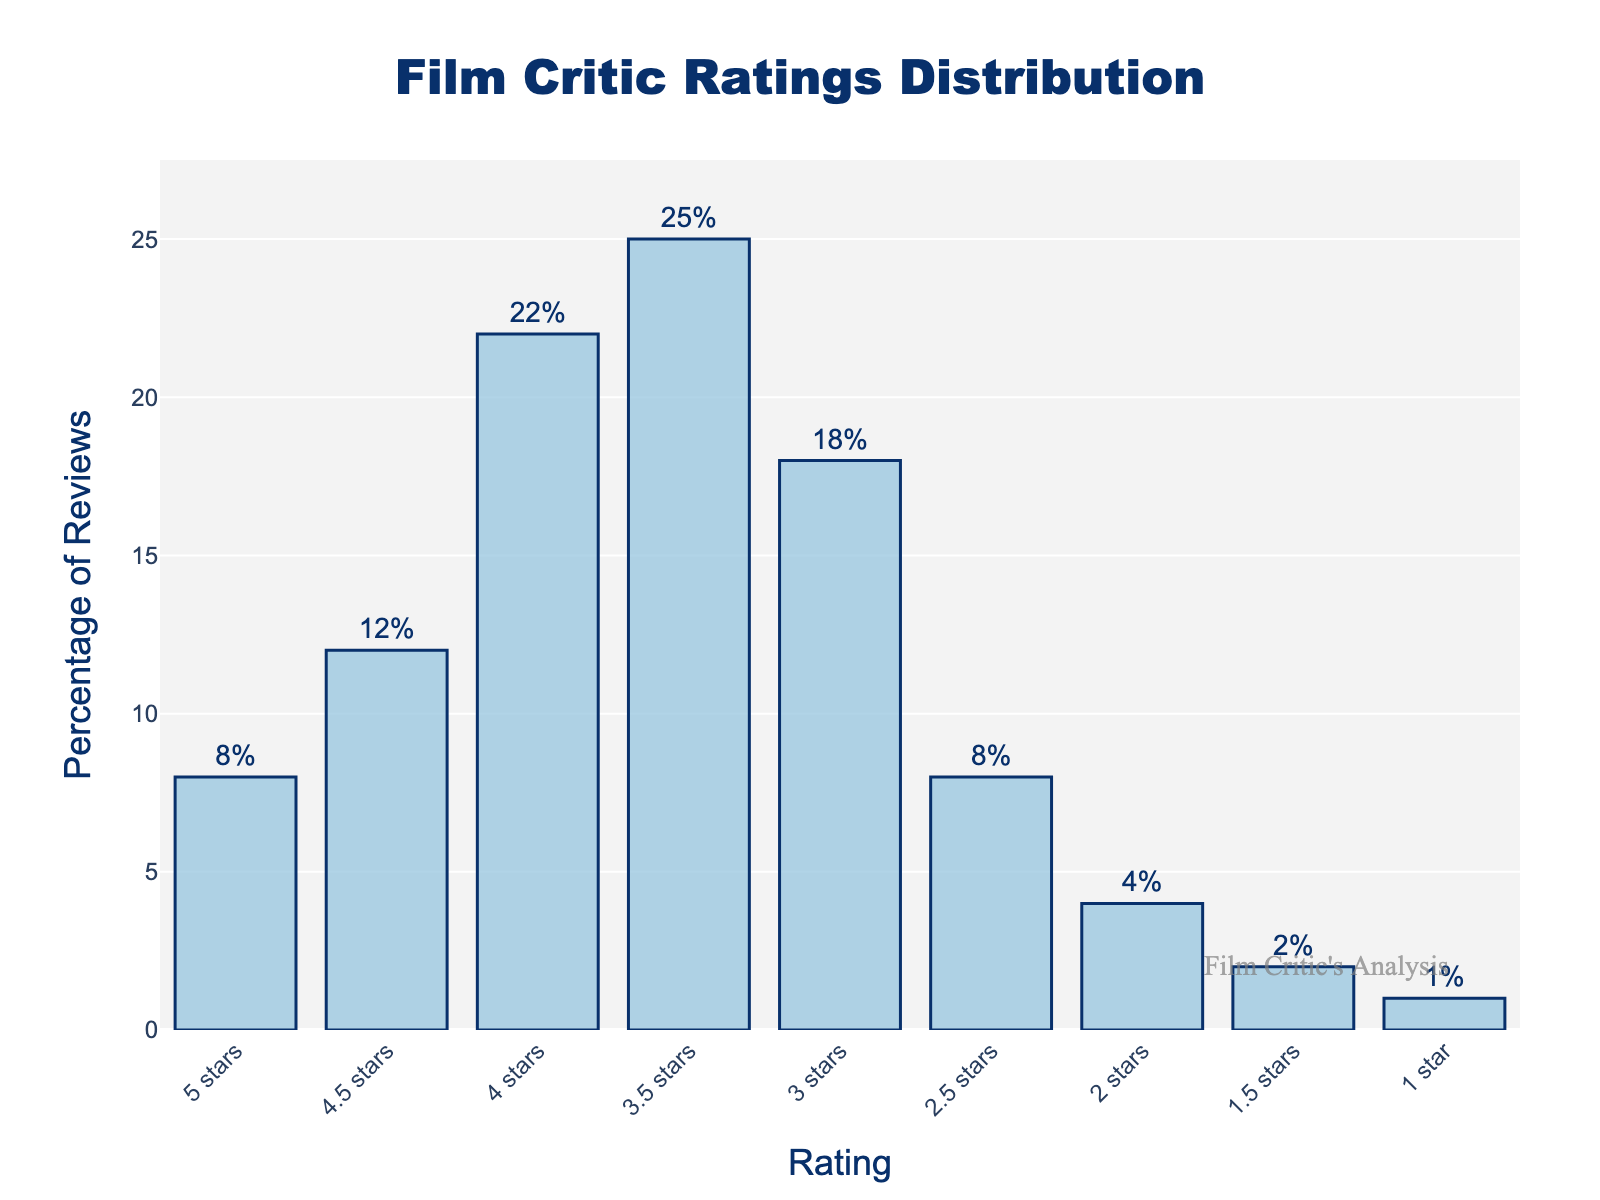What's the most common rating given by film critics? To find the most common rating, look for the highest bar in the bar chart. The tallest bar corresponds to the 3.5 stars rating at 25%.
Answer: 3.5 stars What's the combined percentage of reviews for ratings 5 stars and 1 star? Add the percentages for both 5 stars and 1 star: 8% + 1% = 9%.
Answer: 9% Which rating is more popular: 2.5 stars or 4 stars? Look at the heights of the bars representing 2.5 stars and 4 stars. The bar for 4 stars is significantly taller at 22%, compared to 8% for 2.5 stars.
Answer: 4 stars How much higher is the percentage of 3.5 stars reviews compared to 2 stars reviews? Subtract the percentage of 2 stars reviews from the percentage of 3.5 stars reviews: 25% - 4% = 21%.
Answer: 21% What is the total percentage of reviews that are rated 3 stars or higher? Add the percentages for all ratings 3 stars or higher: 3 stars (18%) + 3.5 stars (25%) + 4 stars (22%) + 4.5 stars (12%) + 5 stars (8%) = 85%.
Answer: 85% Which rating has the least percentage of reviews? Find the shortest bar in the bar chart, which represents the 1 star rating at 1%.
Answer: 1 star Are there more reviews with ratings equal to or higher than 4 stars than those with ratings below 3 stars? Calculate the total percentage of reviews for ratings 4 stars, 4.5 stars, and 5 stars: 4 stars (22%) + 4.5 stars (12%) + 5 stars (8%) = 42%. Then calculate the total percentage for ratings below 3 stars: 1 star (1%) + 1.5 stars (2%) + 2 stars (4%) + 2.5 stars (8%) = 15%. Since 42% > 15%, yes, there are more reviews with ratings equal to or higher than 4 stars.
Answer: Yes What is the difference in percentage between the 4.5 stars and 3 stars ratings? Subtract the percentage of 3 stars reviews from the percentage of 4.5 stars reviews: 12% - 18% = -6%.
Answer: -6% What percentage of reviews is at least 2 stars but less than 4 stars? Add the percentages for the ratings 2, 2.5, 3, and 3.5 stars: 2 stars (4%) + 2.5 stars (8%) + 3 stars (18%) + 3.5 stars (25%) = 55%.
Answer: 55% Is the percentage of 4 stars ratings higher than the sum of 2 stars and 1.5 stars ratings? Calculate the sum of 2 stars and 1.5 stars ratings: 4% + 2% = 6%. Compare that to the percentage of 4 stars ratings, which is 22%. Since 22% > 6%, yes, it is higher.
Answer: Yes 